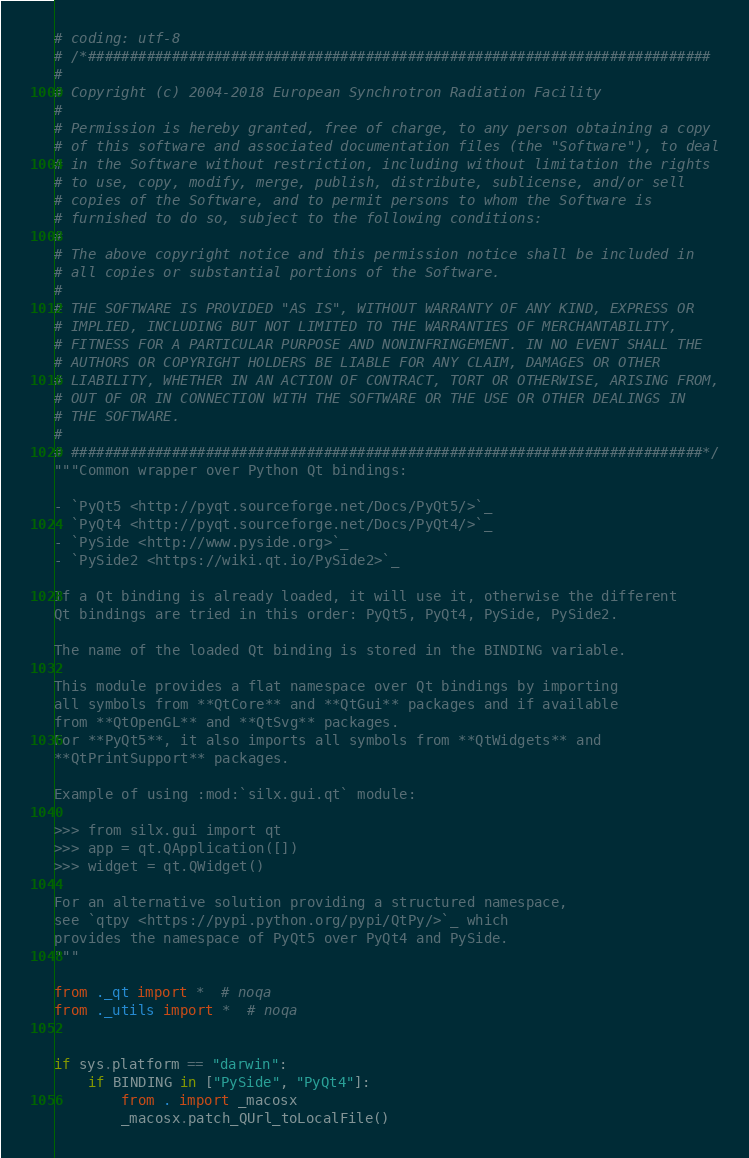<code> <loc_0><loc_0><loc_500><loc_500><_Python_># coding: utf-8
# /*##########################################################################
#
# Copyright (c) 2004-2018 European Synchrotron Radiation Facility
#
# Permission is hereby granted, free of charge, to any person obtaining a copy
# of this software and associated documentation files (the "Software"), to deal
# in the Software without restriction, including without limitation the rights
# to use, copy, modify, merge, publish, distribute, sublicense, and/or sell
# copies of the Software, and to permit persons to whom the Software is
# furnished to do so, subject to the following conditions:
#
# The above copyright notice and this permission notice shall be included in
# all copies or substantial portions of the Software.
#
# THE SOFTWARE IS PROVIDED "AS IS", WITHOUT WARRANTY OF ANY KIND, EXPRESS OR
# IMPLIED, INCLUDING BUT NOT LIMITED TO THE WARRANTIES OF MERCHANTABILITY,
# FITNESS FOR A PARTICULAR PURPOSE AND NONINFRINGEMENT. IN NO EVENT SHALL THE
# AUTHORS OR COPYRIGHT HOLDERS BE LIABLE FOR ANY CLAIM, DAMAGES OR OTHER
# LIABILITY, WHETHER IN AN ACTION OF CONTRACT, TORT OR OTHERWISE, ARISING FROM,
# OUT OF OR IN CONNECTION WITH THE SOFTWARE OR THE USE OR OTHER DEALINGS IN
# THE SOFTWARE.
#
# ###########################################################################*/
"""Common wrapper over Python Qt bindings:

- `PyQt5 <http://pyqt.sourceforge.net/Docs/PyQt5/>`_
- `PyQt4 <http://pyqt.sourceforge.net/Docs/PyQt4/>`_
- `PySide <http://www.pyside.org>`_
- `PySide2 <https://wiki.qt.io/PySide2>`_

If a Qt binding is already loaded, it will use it, otherwise the different
Qt bindings are tried in this order: PyQt5, PyQt4, PySide, PySide2.

The name of the loaded Qt binding is stored in the BINDING variable.

This module provides a flat namespace over Qt bindings by importing
all symbols from **QtCore** and **QtGui** packages and if available
from **QtOpenGL** and **QtSvg** packages.
For **PyQt5**, it also imports all symbols from **QtWidgets** and
**QtPrintSupport** packages.

Example of using :mod:`silx.gui.qt` module:

>>> from silx.gui import qt
>>> app = qt.QApplication([])
>>> widget = qt.QWidget()

For an alternative solution providing a structured namespace,
see `qtpy <https://pypi.python.org/pypi/QtPy/>`_ which
provides the namespace of PyQt5 over PyQt4 and PySide.
"""

from ._qt import *  # noqa
from ._utils import *  # noqa


if sys.platform == "darwin":
    if BINDING in ["PySide", "PyQt4"]:
        from . import _macosx
        _macosx.patch_QUrl_toLocalFile()
</code> 